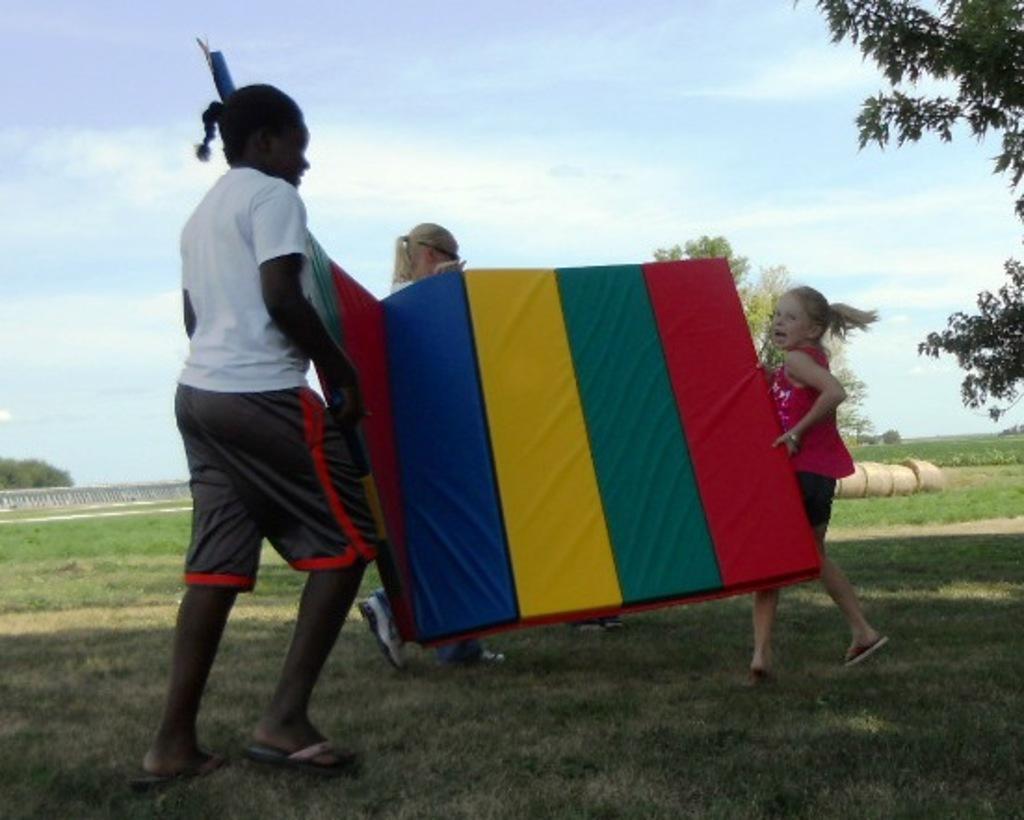How would you summarize this image in a sentence or two? In this image I can see three people holding an object which is in red, green, yellow and blue color. In the background I can see many trees and few objects on the ground. I can see the clouds and the sky. 